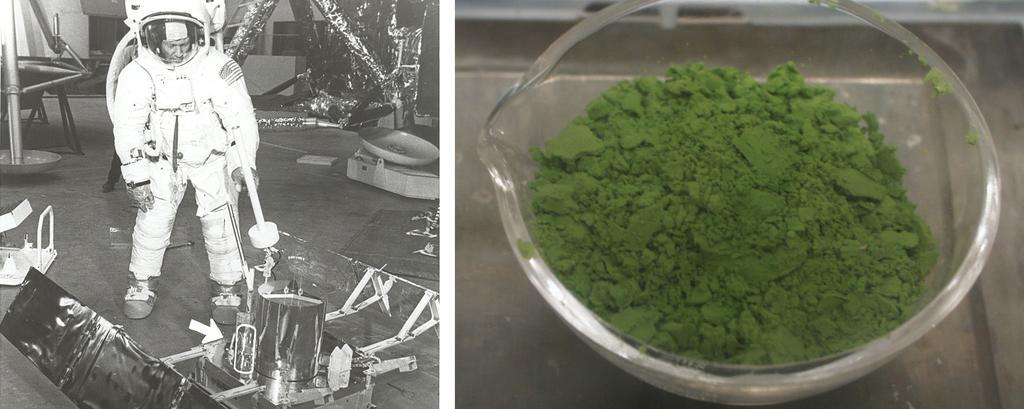In one or two sentences, can you explain what this image depicts? In the image we can see two different pictures. At the left picture we can see a man wearing suit, gloves, shoes and helmet and the person is holding an object in hand. In front of the person there is an object. There is a floor and many other things around. In the right image we can see a bowl, in the bowl there is a powder, green in color. 